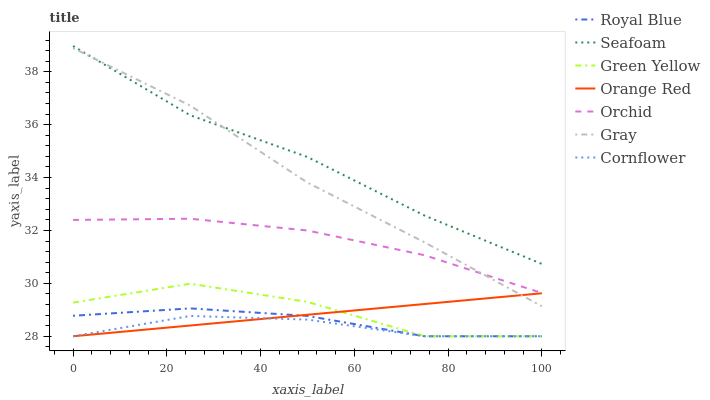Does Cornflower have the minimum area under the curve?
Answer yes or no. Yes. Does Seafoam have the maximum area under the curve?
Answer yes or no. Yes. Does Seafoam have the minimum area under the curve?
Answer yes or no. No. Does Cornflower have the maximum area under the curve?
Answer yes or no. No. Is Orange Red the smoothest?
Answer yes or no. Yes. Is Green Yellow the roughest?
Answer yes or no. Yes. Is Cornflower the smoothest?
Answer yes or no. No. Is Cornflower the roughest?
Answer yes or no. No. Does Cornflower have the lowest value?
Answer yes or no. Yes. Does Seafoam have the lowest value?
Answer yes or no. No. Does Seafoam have the highest value?
Answer yes or no. Yes. Does Cornflower have the highest value?
Answer yes or no. No. Is Royal Blue less than Seafoam?
Answer yes or no. Yes. Is Gray greater than Royal Blue?
Answer yes or no. Yes. Does Orchid intersect Gray?
Answer yes or no. Yes. Is Orchid less than Gray?
Answer yes or no. No. Is Orchid greater than Gray?
Answer yes or no. No. Does Royal Blue intersect Seafoam?
Answer yes or no. No. 